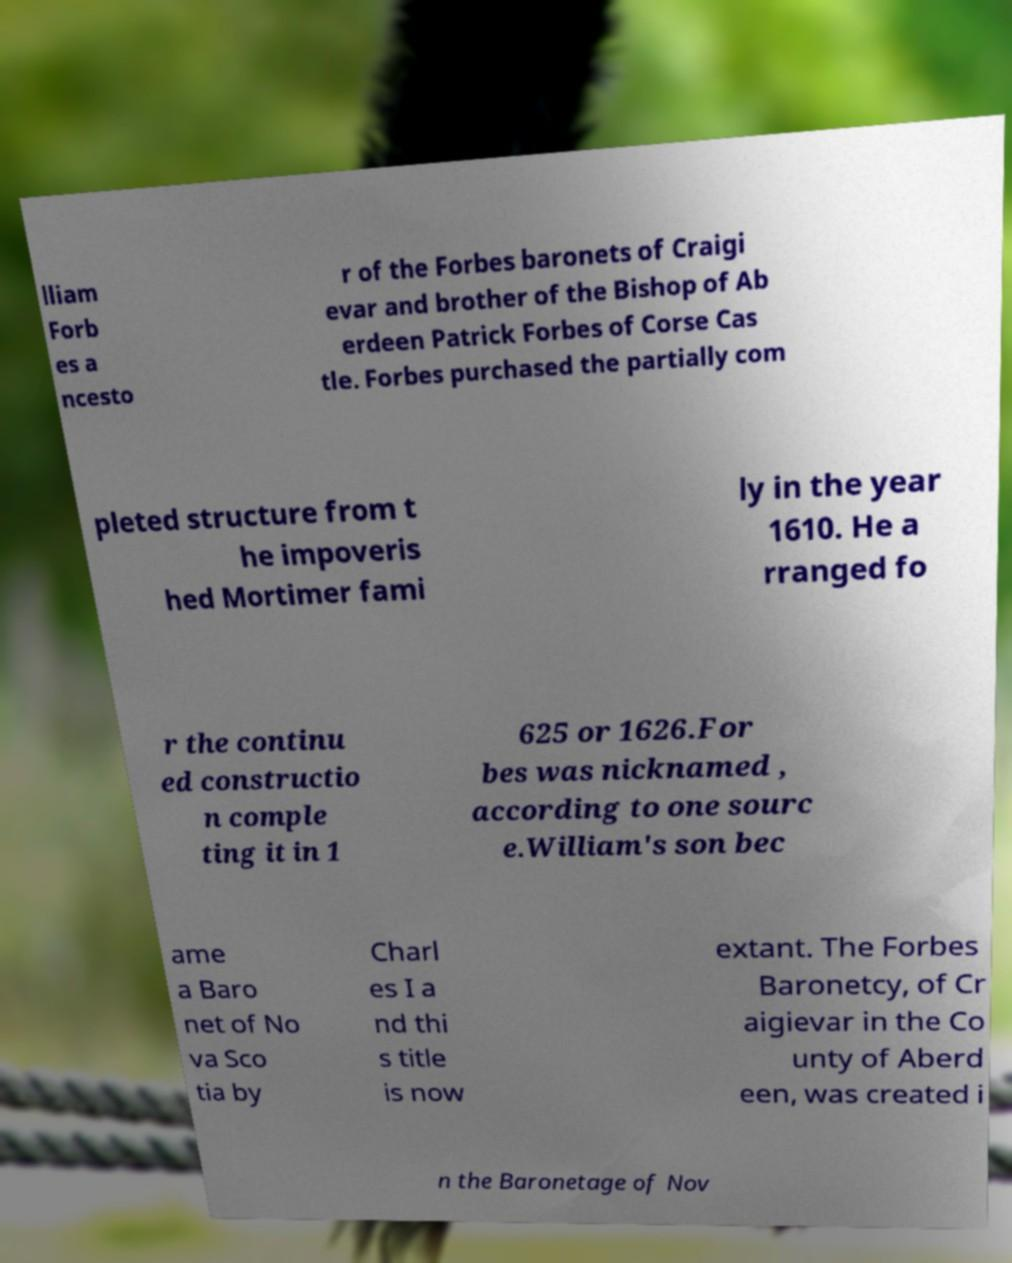Could you extract and type out the text from this image? lliam Forb es a ncesto r of the Forbes baronets of Craigi evar and brother of the Bishop of Ab erdeen Patrick Forbes of Corse Cas tle. Forbes purchased the partially com pleted structure from t he impoveris hed Mortimer fami ly in the year 1610. He a rranged fo r the continu ed constructio n comple ting it in 1 625 or 1626.For bes was nicknamed , according to one sourc e.William's son bec ame a Baro net of No va Sco tia by Charl es I a nd thi s title is now extant. The Forbes Baronetcy, of Cr aigievar in the Co unty of Aberd een, was created i n the Baronetage of Nov 